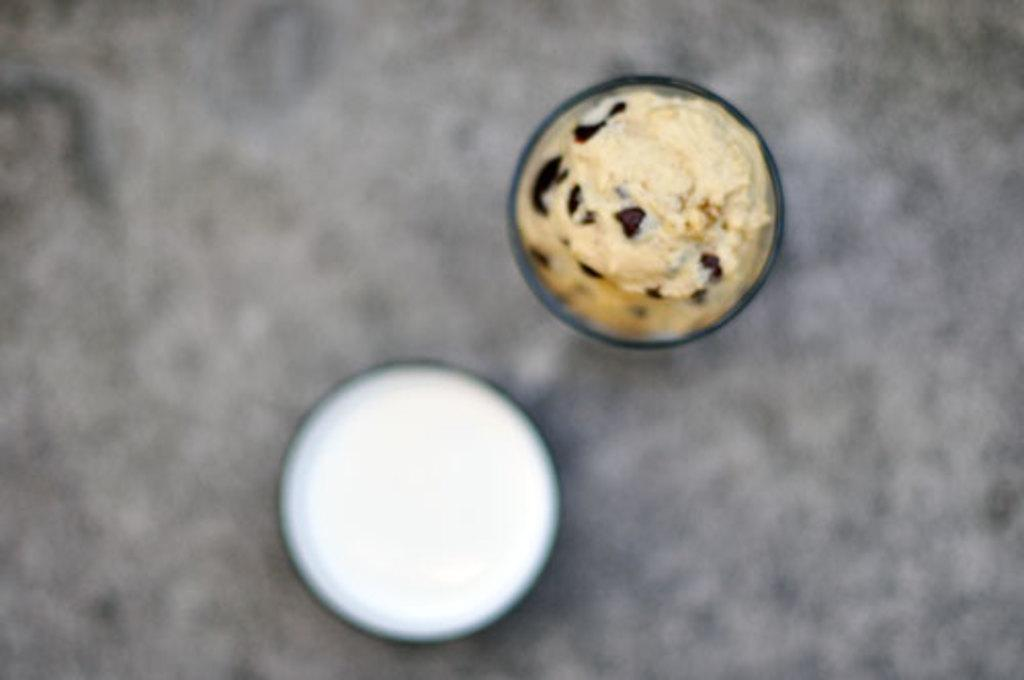What type of containers are visible in the image? There are glass bowls in the image. What is inside the glass bowls? The glass bowls contain food. What type of dock can be seen in the image? There is no dock present in the image. What is the source of the spark in the image? There is no spark present in the image. 